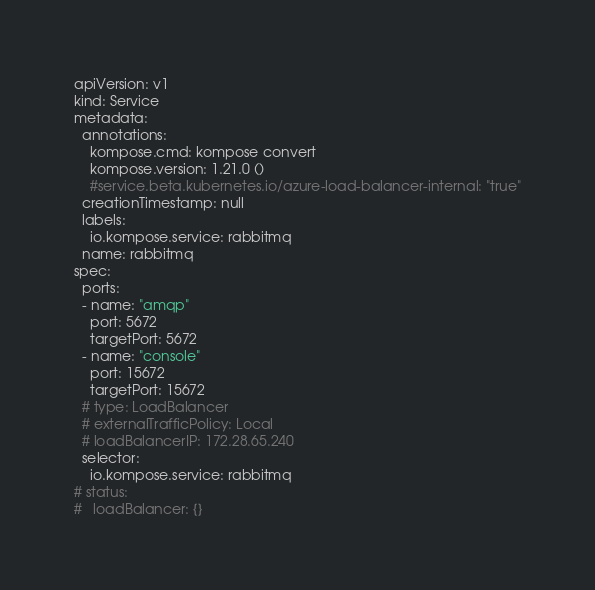<code> <loc_0><loc_0><loc_500><loc_500><_YAML_>apiVersion: v1
kind: Service
metadata:
  annotations:
    kompose.cmd: kompose convert
    kompose.version: 1.21.0 ()
    #service.beta.kubernetes.io/azure-load-balancer-internal: "true"
  creationTimestamp: null
  labels:
    io.kompose.service: rabbitmq
  name: rabbitmq
spec:
  ports:
  - name: "amqp"
    port: 5672
    targetPort: 5672
  - name: "console"
    port: 15672
    targetPort: 15672
  # type: LoadBalancer
  # externalTrafficPolicy: Local
  # loadBalancerIP: 172.28.65.240
  selector:
    io.kompose.service: rabbitmq
# status:
#   loadBalancer: {}
</code> 